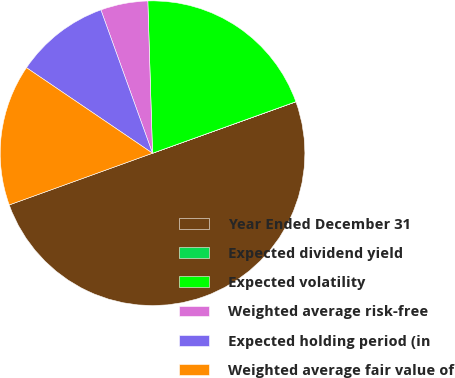Convert chart to OTSL. <chart><loc_0><loc_0><loc_500><loc_500><pie_chart><fcel>Year Ended December 31<fcel>Expected dividend yield<fcel>Expected volatility<fcel>Weighted average risk-free<fcel>Expected holding period (in<fcel>Weighted average fair value of<nl><fcel>49.97%<fcel>0.01%<fcel>20.0%<fcel>5.01%<fcel>10.01%<fcel>15.0%<nl></chart> 